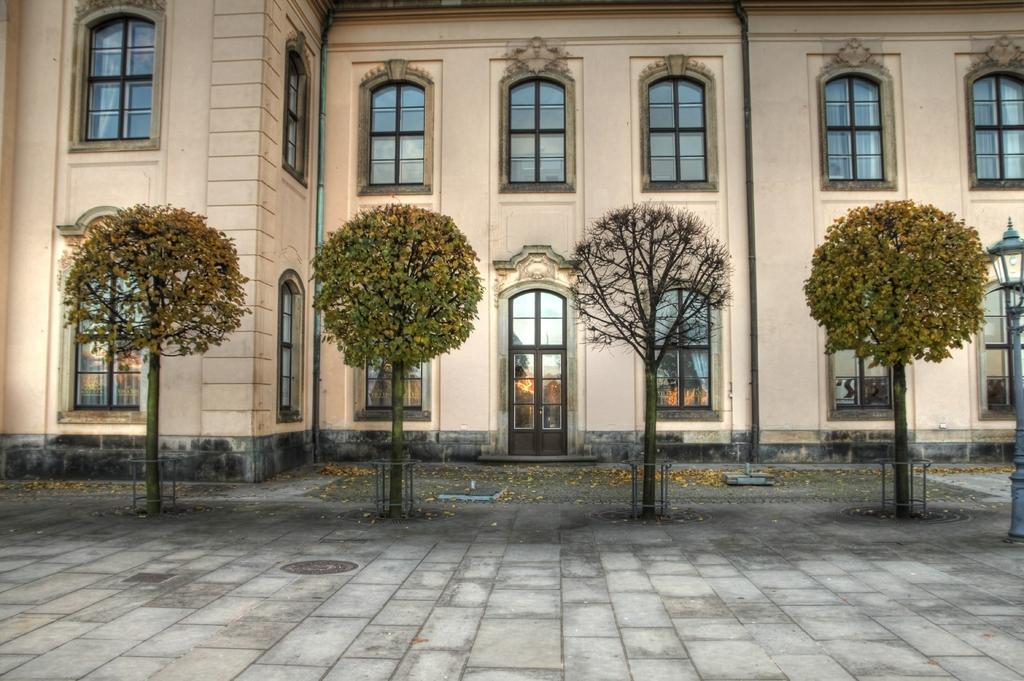How would you summarize this image in a sentence or two? In this picture i can see the building. In-front of the building i can see the trees and steel net box. At the top i can see many windows, beside that there is a door. On the right there is a street light. 